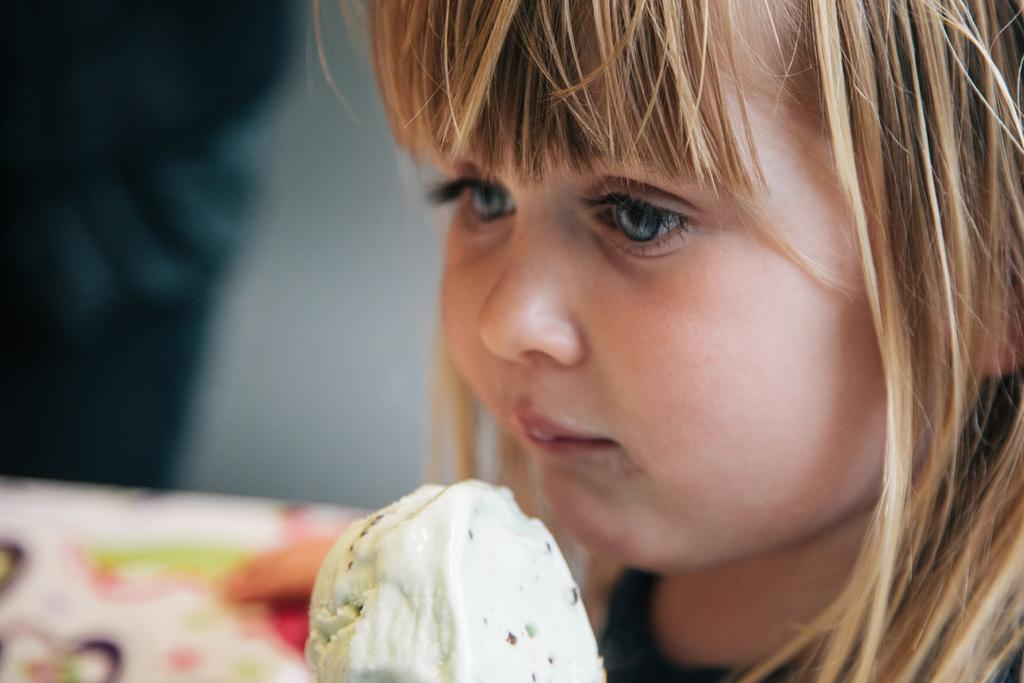What is the main subject of the image? The main subject of the image is a kid. What is the kid holding in the image? The kid is holding an ice cream. Can you describe the background of the image? There is an object and a wall in the background of the image. What type of wool is the kid wearing in the image? There is no mention of wool or any clothing in the image, so it cannot be determined what type of wool the kid might be wearing. 